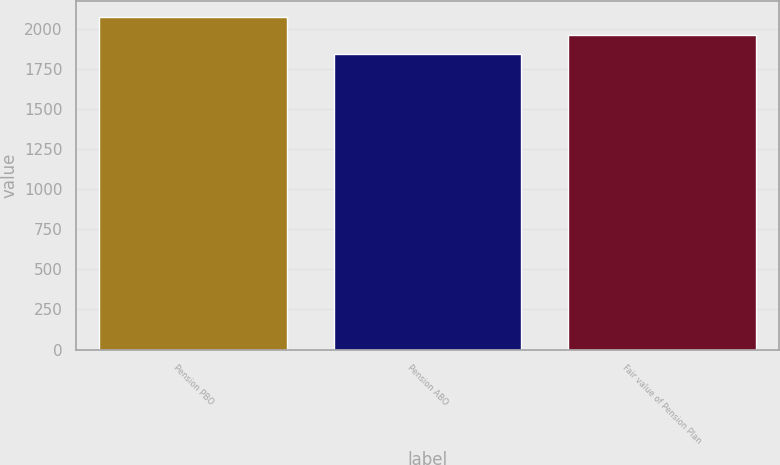Convert chart. <chart><loc_0><loc_0><loc_500><loc_500><bar_chart><fcel>Pension PBO<fcel>Pension ABO<fcel>Fair value of Pension Plan<nl><fcel>2073<fcel>1843<fcel>1964<nl></chart> 